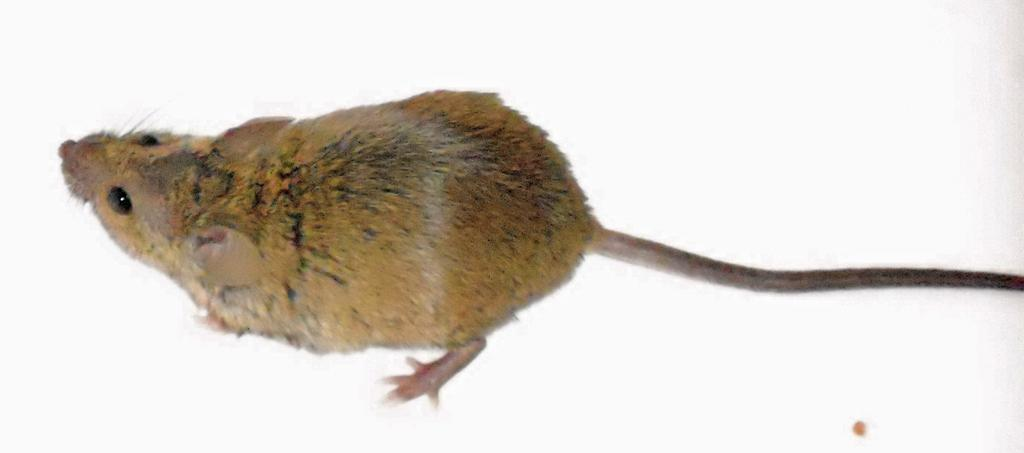What type of animal is in the image? There is a rat in the image. What color is the background of the image? The background of the image is white. What letter is the rat holding in the image? There is no letter present in the image, and the rat is not holding anything. 